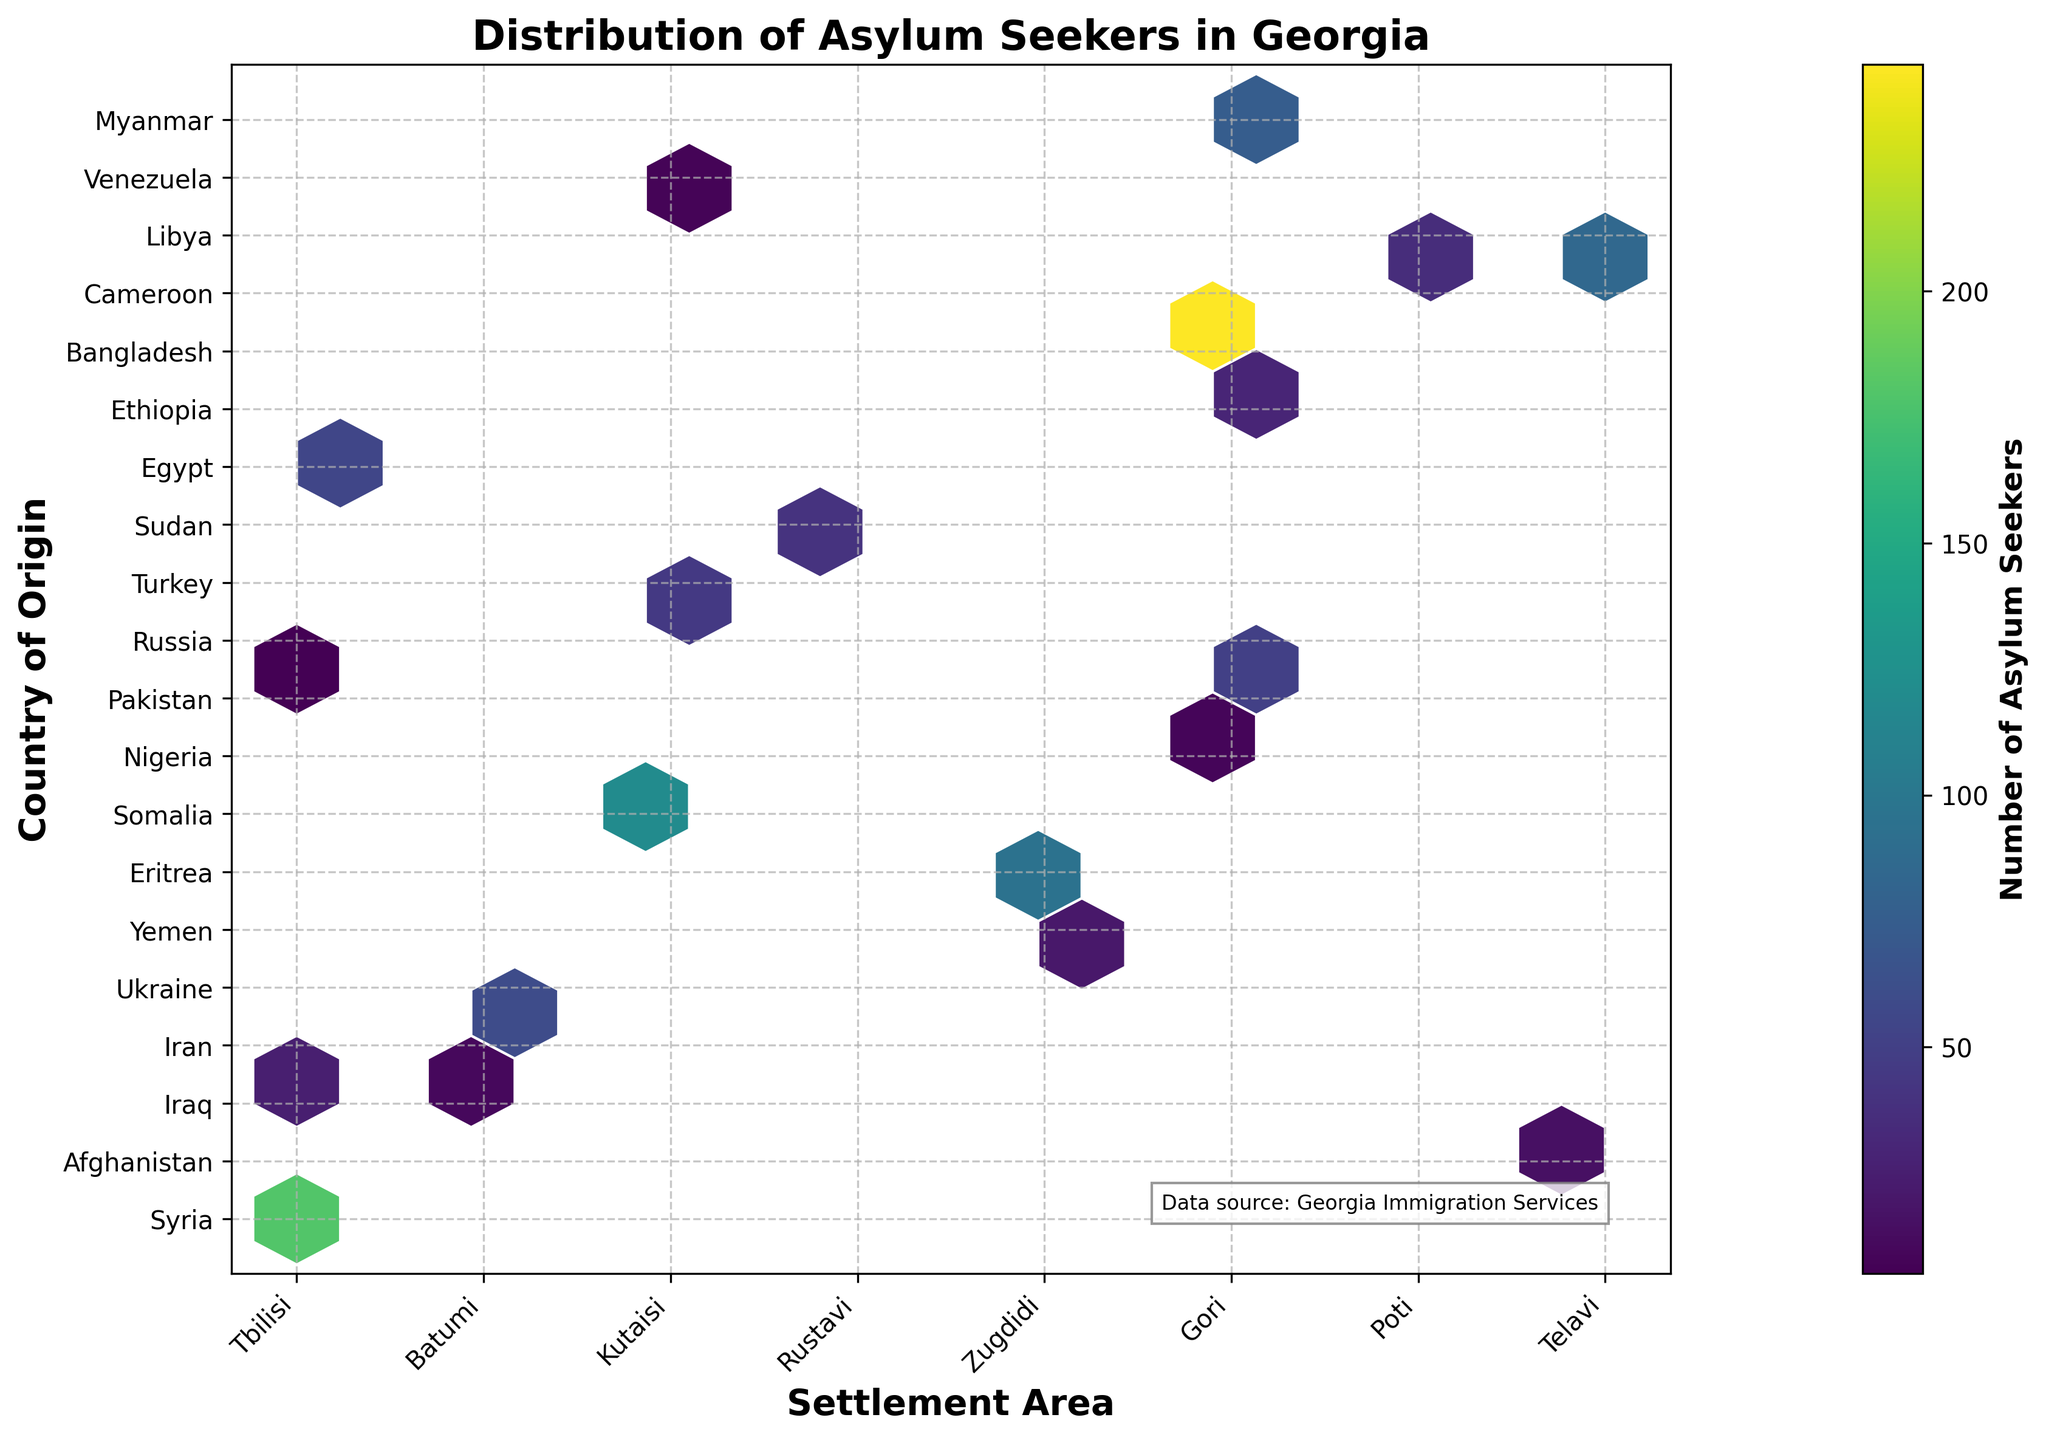What is the title of the graph? The title of the graph is displayed at the top center of the figure. It is "Distribution of Asylum Seekers in Georgia".
Answer: Distribution of Asylum Seekers in Georgia Which settlement area has the highest number of asylum seekers from Syria? Locate the cell in the hexbin plot corresponding to Syria (y-axis) and check the color intensity for each settlement area (x-axis). The darkest cell indicates the highest number. In this case, the darkest cell for Syria is aligned with Tbilisi.
Answer: Tbilisi How many countries of origin are shown in the figure? Count the number of unique tick labels on the y-axis, each representing a different country of origin. There are 20 unique tick labels.
Answer: 20 Which settlement area hosts the fewest asylum seekers from Libya? Find the cell corresponding to Libya (y-axis) and observe the color intensity for each settlement area (x-axis). The color is faintest for Tbilisi, indicating the fewest asylum seekers.
Answer: Tbilisi What is the most common settlement area for asylum seekers from Africa? Identify African countries on the y-axis: Eritrea, Somalia, Nigeria, Sudan, Egypt, Ethiopia, Cameroon, Libya. Check the settlement areas (x-axis) associated with these countries and find the mode. Batumi and Gori share the most common settlement.
Answer: Batumi, Gori Which country of origin has asylum seekers settled in the most different areas? For each country on the y-axis, count the number of different settlement areas on the x-axis where asylum seekers are settled. Ukraine, with unique cells for multiple settlement areas, indicates more diversity.
Answer: Ukraine What is the total number of asylum seekers depicted in the figure? Sum the number of asylum seekers from each country of origin provided in the dataset. Calculate: 245+180+120+95+85+75+60+55+50+45+40+35+30+25+20+15+10+8+7+5 = 1205.
Answer: 1205 Which settlement area has the highest overall number of asylum seekers? Sum the color intensity (representing the number of asylum seekers) for each settlement area across all countries. Tbilisi has the highest combined color intensity.
Answer: Tbilisi Between Batumi and Kutaisi, which settlement area hosts more asylum seekers from the Middle East? Identify Middle Eastern countries (Syria, Iraq, Iran, Yemen, Pakistan) and compare the number of asylum seekers in Batumi and Kutaisi by summing up the cells. Batumi has Afghanistan (180), Somalia (55), and Egypt (25) compared to Kutaisi's Iraq (120), Pakistan (45), and Venezuela (7), leading to 260 in Batumi vs. 165 in Kutaisi.
Answer: Batumi Are there more asylum seekers from African countries or Middle Eastern countries in Tbilisi? List African countries (Nigeria, Sudan, Eritrea, Cameroon, Libya) and Middle Eastern countries (Syria, Iraq, Iran, Yemen, Pakistan) and calculate: Tbilisi: Nigeria (50), Sudan (30), Libya (8), equals 88; Middle Eastern: Syria (245), Yemen (75), equals 320.
Answer: Middle Eastern countries 